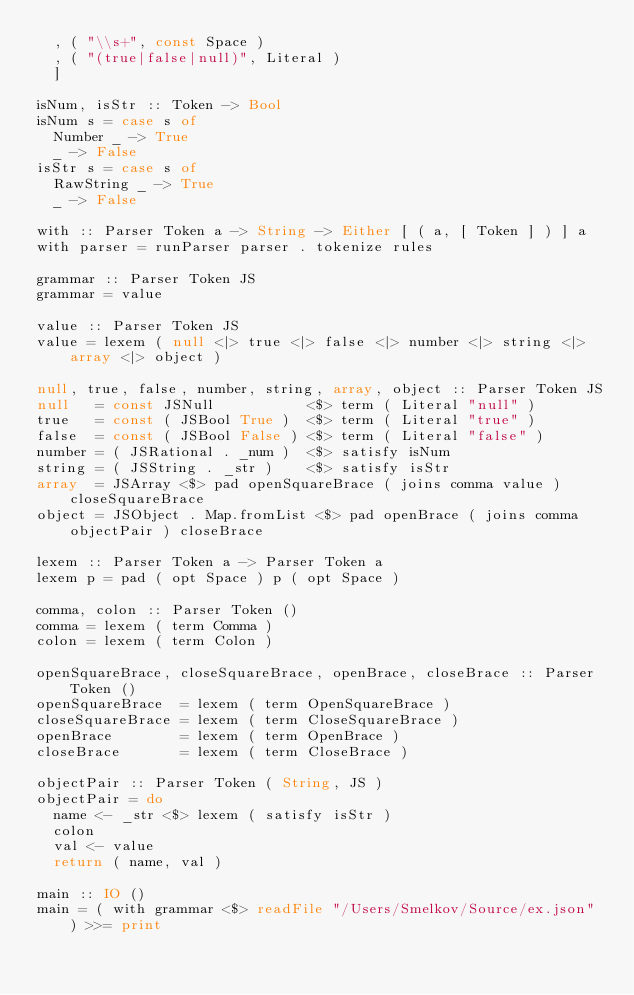Convert code to text. <code><loc_0><loc_0><loc_500><loc_500><_Haskell_>  , ( "\\s+", const Space )
  , ( "(true|false|null)", Literal )
  ]

isNum, isStr :: Token -> Bool
isNum s = case s of
  Number _ -> True
  _ -> False
isStr s = case s of
  RawString _ -> True
  _ -> False

with :: Parser Token a -> String -> Either [ ( a, [ Token ] ) ] a
with parser = runParser parser . tokenize rules 

grammar :: Parser Token JS
grammar = value

value :: Parser Token JS
value = lexem ( null <|> true <|> false <|> number <|> string <|> array <|> object )

null, true, false, number, string, array, object :: Parser Token JS
null   = const JSNull           <$> term ( Literal "null" )
true   = const ( JSBool True )  <$> term ( Literal "true" )
false  = const ( JSBool False ) <$> term ( Literal "false" )
number = ( JSRational . _num )  <$> satisfy isNum
string = ( JSString . _str )    <$> satisfy isStr
array  = JSArray <$> pad openSquareBrace ( joins comma value ) closeSquareBrace
object = JSObject . Map.fromList <$> pad openBrace ( joins comma objectPair ) closeBrace

lexem :: Parser Token a -> Parser Token a
lexem p = pad ( opt Space ) p ( opt Space )

comma, colon :: Parser Token ()
comma = lexem ( term Comma )
colon = lexem ( term Colon )

openSquareBrace, closeSquareBrace, openBrace, closeBrace :: Parser Token ()
openSquareBrace  = lexem ( term OpenSquareBrace )
closeSquareBrace = lexem ( term CloseSquareBrace )
openBrace        = lexem ( term OpenBrace )
closeBrace       = lexem ( term CloseBrace )

objectPair :: Parser Token ( String, JS )
objectPair = do
  name <- _str <$> lexem ( satisfy isStr )
  colon
  val <- value
  return ( name, val )

main :: IO ()
main = ( with grammar <$> readFile "/Users/Smelkov/Source/ex.json" ) >>= print
</code> 